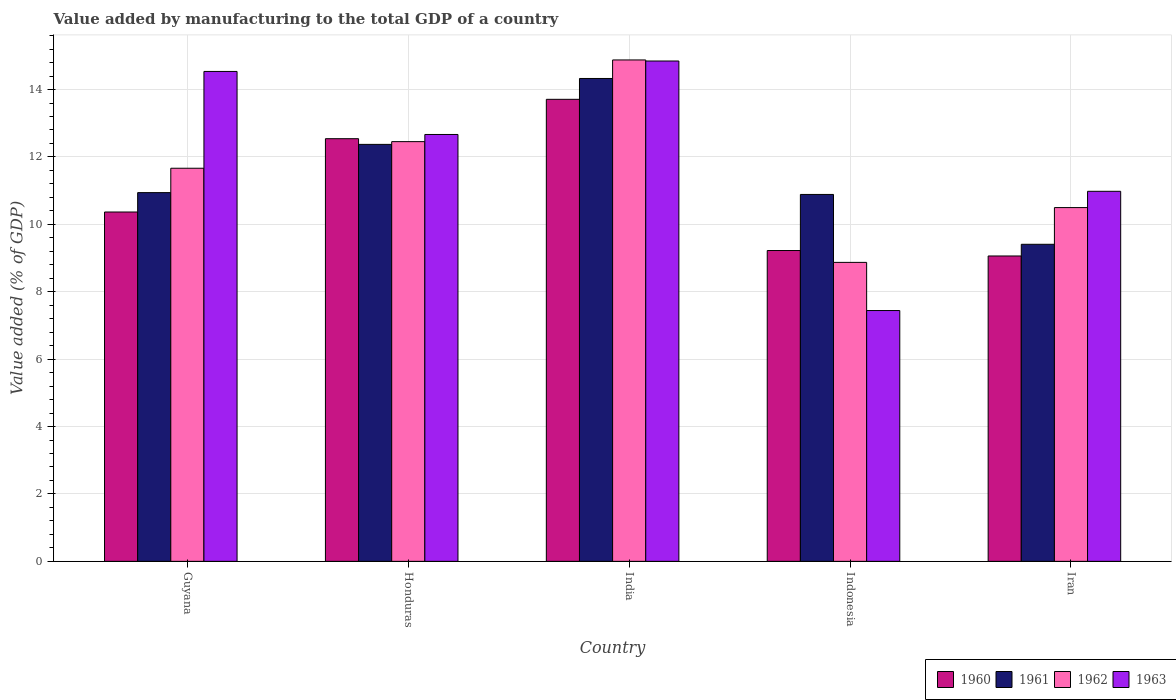How many groups of bars are there?
Give a very brief answer. 5. What is the label of the 1st group of bars from the left?
Ensure brevity in your answer.  Guyana. In how many cases, is the number of bars for a given country not equal to the number of legend labels?
Your answer should be compact. 0. What is the value added by manufacturing to the total GDP in 1961 in Indonesia?
Give a very brief answer. 10.89. Across all countries, what is the maximum value added by manufacturing to the total GDP in 1961?
Make the answer very short. 14.33. Across all countries, what is the minimum value added by manufacturing to the total GDP in 1962?
Give a very brief answer. 8.87. In which country was the value added by manufacturing to the total GDP in 1961 maximum?
Your answer should be compact. India. In which country was the value added by manufacturing to the total GDP in 1963 minimum?
Your answer should be compact. Indonesia. What is the total value added by manufacturing to the total GDP in 1960 in the graph?
Provide a succinct answer. 54.9. What is the difference between the value added by manufacturing to the total GDP in 1963 in Guyana and that in Indonesia?
Your answer should be compact. 7.09. What is the difference between the value added by manufacturing to the total GDP in 1960 in Guyana and the value added by manufacturing to the total GDP in 1962 in Iran?
Offer a terse response. -0.13. What is the average value added by manufacturing to the total GDP in 1960 per country?
Give a very brief answer. 10.98. What is the difference between the value added by manufacturing to the total GDP of/in 1960 and value added by manufacturing to the total GDP of/in 1963 in Iran?
Your answer should be compact. -1.92. What is the ratio of the value added by manufacturing to the total GDP in 1960 in Honduras to that in Indonesia?
Your response must be concise. 1.36. Is the value added by manufacturing to the total GDP in 1963 in Indonesia less than that in Iran?
Your answer should be very brief. Yes. What is the difference between the highest and the second highest value added by manufacturing to the total GDP in 1961?
Offer a very short reply. -1.43. What is the difference between the highest and the lowest value added by manufacturing to the total GDP in 1962?
Give a very brief answer. 6.01. Is the sum of the value added by manufacturing to the total GDP in 1961 in Honduras and Indonesia greater than the maximum value added by manufacturing to the total GDP in 1962 across all countries?
Your answer should be compact. Yes. What does the 4th bar from the left in Honduras represents?
Keep it short and to the point. 1963. How many bars are there?
Give a very brief answer. 20. Are the values on the major ticks of Y-axis written in scientific E-notation?
Your answer should be very brief. No. Where does the legend appear in the graph?
Give a very brief answer. Bottom right. What is the title of the graph?
Ensure brevity in your answer.  Value added by manufacturing to the total GDP of a country. What is the label or title of the Y-axis?
Your answer should be very brief. Value added (% of GDP). What is the Value added (% of GDP) of 1960 in Guyana?
Make the answer very short. 10.37. What is the Value added (% of GDP) in 1961 in Guyana?
Ensure brevity in your answer.  10.94. What is the Value added (% of GDP) of 1962 in Guyana?
Provide a succinct answer. 11.66. What is the Value added (% of GDP) of 1963 in Guyana?
Ensure brevity in your answer.  14.54. What is the Value added (% of GDP) in 1960 in Honduras?
Give a very brief answer. 12.54. What is the Value added (% of GDP) of 1961 in Honduras?
Offer a terse response. 12.37. What is the Value added (% of GDP) in 1962 in Honduras?
Provide a short and direct response. 12.45. What is the Value added (% of GDP) of 1963 in Honduras?
Offer a very short reply. 12.67. What is the Value added (% of GDP) of 1960 in India?
Ensure brevity in your answer.  13.71. What is the Value added (% of GDP) of 1961 in India?
Offer a terse response. 14.33. What is the Value added (% of GDP) in 1962 in India?
Ensure brevity in your answer.  14.88. What is the Value added (% of GDP) in 1963 in India?
Ensure brevity in your answer.  14.85. What is the Value added (% of GDP) in 1960 in Indonesia?
Your answer should be very brief. 9.22. What is the Value added (% of GDP) of 1961 in Indonesia?
Your response must be concise. 10.89. What is the Value added (% of GDP) of 1962 in Indonesia?
Your answer should be very brief. 8.87. What is the Value added (% of GDP) of 1963 in Indonesia?
Provide a short and direct response. 7.44. What is the Value added (% of GDP) in 1960 in Iran?
Offer a terse response. 9.06. What is the Value added (% of GDP) in 1961 in Iran?
Your answer should be very brief. 9.41. What is the Value added (% of GDP) of 1962 in Iran?
Provide a succinct answer. 10.5. What is the Value added (% of GDP) in 1963 in Iran?
Keep it short and to the point. 10.98. Across all countries, what is the maximum Value added (% of GDP) of 1960?
Your answer should be compact. 13.71. Across all countries, what is the maximum Value added (% of GDP) in 1961?
Provide a short and direct response. 14.33. Across all countries, what is the maximum Value added (% of GDP) of 1962?
Your answer should be compact. 14.88. Across all countries, what is the maximum Value added (% of GDP) of 1963?
Offer a very short reply. 14.85. Across all countries, what is the minimum Value added (% of GDP) in 1960?
Offer a terse response. 9.06. Across all countries, what is the minimum Value added (% of GDP) in 1961?
Your answer should be very brief. 9.41. Across all countries, what is the minimum Value added (% of GDP) in 1962?
Offer a very short reply. 8.87. Across all countries, what is the minimum Value added (% of GDP) of 1963?
Give a very brief answer. 7.44. What is the total Value added (% of GDP) in 1960 in the graph?
Provide a succinct answer. 54.9. What is the total Value added (% of GDP) in 1961 in the graph?
Ensure brevity in your answer.  57.94. What is the total Value added (% of GDP) in 1962 in the graph?
Keep it short and to the point. 58.37. What is the total Value added (% of GDP) in 1963 in the graph?
Make the answer very short. 60.47. What is the difference between the Value added (% of GDP) of 1960 in Guyana and that in Honduras?
Provide a succinct answer. -2.18. What is the difference between the Value added (% of GDP) of 1961 in Guyana and that in Honduras?
Your answer should be compact. -1.43. What is the difference between the Value added (% of GDP) of 1962 in Guyana and that in Honduras?
Offer a very short reply. -0.79. What is the difference between the Value added (% of GDP) in 1963 in Guyana and that in Honduras?
Offer a very short reply. 1.87. What is the difference between the Value added (% of GDP) in 1960 in Guyana and that in India?
Offer a very short reply. -3.34. What is the difference between the Value added (% of GDP) of 1961 in Guyana and that in India?
Provide a short and direct response. -3.39. What is the difference between the Value added (% of GDP) in 1962 in Guyana and that in India?
Make the answer very short. -3.21. What is the difference between the Value added (% of GDP) of 1963 in Guyana and that in India?
Ensure brevity in your answer.  -0.31. What is the difference between the Value added (% of GDP) of 1960 in Guyana and that in Indonesia?
Ensure brevity in your answer.  1.14. What is the difference between the Value added (% of GDP) of 1961 in Guyana and that in Indonesia?
Provide a succinct answer. 0.05. What is the difference between the Value added (% of GDP) of 1962 in Guyana and that in Indonesia?
Give a very brief answer. 2.79. What is the difference between the Value added (% of GDP) of 1963 in Guyana and that in Indonesia?
Your response must be concise. 7.09. What is the difference between the Value added (% of GDP) of 1960 in Guyana and that in Iran?
Provide a succinct answer. 1.3. What is the difference between the Value added (% of GDP) of 1961 in Guyana and that in Iran?
Provide a short and direct response. 1.53. What is the difference between the Value added (% of GDP) in 1962 in Guyana and that in Iran?
Give a very brief answer. 1.17. What is the difference between the Value added (% of GDP) of 1963 in Guyana and that in Iran?
Your answer should be very brief. 3.56. What is the difference between the Value added (% of GDP) of 1960 in Honduras and that in India?
Keep it short and to the point. -1.17. What is the difference between the Value added (% of GDP) of 1961 in Honduras and that in India?
Your answer should be very brief. -1.96. What is the difference between the Value added (% of GDP) in 1962 in Honduras and that in India?
Offer a terse response. -2.42. What is the difference between the Value added (% of GDP) of 1963 in Honduras and that in India?
Ensure brevity in your answer.  -2.18. What is the difference between the Value added (% of GDP) in 1960 in Honduras and that in Indonesia?
Your answer should be compact. 3.32. What is the difference between the Value added (% of GDP) in 1961 in Honduras and that in Indonesia?
Offer a very short reply. 1.49. What is the difference between the Value added (% of GDP) in 1962 in Honduras and that in Indonesia?
Keep it short and to the point. 3.58. What is the difference between the Value added (% of GDP) of 1963 in Honduras and that in Indonesia?
Your answer should be very brief. 5.22. What is the difference between the Value added (% of GDP) in 1960 in Honduras and that in Iran?
Your answer should be very brief. 3.48. What is the difference between the Value added (% of GDP) of 1961 in Honduras and that in Iran?
Give a very brief answer. 2.96. What is the difference between the Value added (% of GDP) of 1962 in Honduras and that in Iran?
Provide a short and direct response. 1.96. What is the difference between the Value added (% of GDP) of 1963 in Honduras and that in Iran?
Keep it short and to the point. 1.69. What is the difference between the Value added (% of GDP) in 1960 in India and that in Indonesia?
Provide a short and direct response. 4.49. What is the difference between the Value added (% of GDP) of 1961 in India and that in Indonesia?
Give a very brief answer. 3.44. What is the difference between the Value added (% of GDP) of 1962 in India and that in Indonesia?
Make the answer very short. 6.01. What is the difference between the Value added (% of GDP) in 1963 in India and that in Indonesia?
Ensure brevity in your answer.  7.4. What is the difference between the Value added (% of GDP) of 1960 in India and that in Iran?
Offer a very short reply. 4.65. What is the difference between the Value added (% of GDP) of 1961 in India and that in Iran?
Your response must be concise. 4.92. What is the difference between the Value added (% of GDP) in 1962 in India and that in Iran?
Ensure brevity in your answer.  4.38. What is the difference between the Value added (% of GDP) in 1963 in India and that in Iran?
Provide a succinct answer. 3.87. What is the difference between the Value added (% of GDP) in 1960 in Indonesia and that in Iran?
Ensure brevity in your answer.  0.16. What is the difference between the Value added (% of GDP) in 1961 in Indonesia and that in Iran?
Provide a short and direct response. 1.48. What is the difference between the Value added (% of GDP) in 1962 in Indonesia and that in Iran?
Provide a short and direct response. -1.63. What is the difference between the Value added (% of GDP) of 1963 in Indonesia and that in Iran?
Give a very brief answer. -3.54. What is the difference between the Value added (% of GDP) in 1960 in Guyana and the Value added (% of GDP) in 1961 in Honduras?
Your answer should be compact. -2.01. What is the difference between the Value added (% of GDP) in 1960 in Guyana and the Value added (% of GDP) in 1962 in Honduras?
Provide a short and direct response. -2.09. What is the difference between the Value added (% of GDP) of 1960 in Guyana and the Value added (% of GDP) of 1963 in Honduras?
Ensure brevity in your answer.  -2.3. What is the difference between the Value added (% of GDP) of 1961 in Guyana and the Value added (% of GDP) of 1962 in Honduras?
Ensure brevity in your answer.  -1.51. What is the difference between the Value added (% of GDP) of 1961 in Guyana and the Value added (% of GDP) of 1963 in Honduras?
Your answer should be compact. -1.73. What is the difference between the Value added (% of GDP) in 1962 in Guyana and the Value added (% of GDP) in 1963 in Honduras?
Your answer should be compact. -1. What is the difference between the Value added (% of GDP) of 1960 in Guyana and the Value added (% of GDP) of 1961 in India?
Your answer should be very brief. -3.96. What is the difference between the Value added (% of GDP) in 1960 in Guyana and the Value added (% of GDP) in 1962 in India?
Provide a short and direct response. -4.51. What is the difference between the Value added (% of GDP) of 1960 in Guyana and the Value added (% of GDP) of 1963 in India?
Ensure brevity in your answer.  -4.48. What is the difference between the Value added (% of GDP) of 1961 in Guyana and the Value added (% of GDP) of 1962 in India?
Your answer should be compact. -3.94. What is the difference between the Value added (% of GDP) in 1961 in Guyana and the Value added (% of GDP) in 1963 in India?
Keep it short and to the point. -3.91. What is the difference between the Value added (% of GDP) in 1962 in Guyana and the Value added (% of GDP) in 1963 in India?
Give a very brief answer. -3.18. What is the difference between the Value added (% of GDP) in 1960 in Guyana and the Value added (% of GDP) in 1961 in Indonesia?
Keep it short and to the point. -0.52. What is the difference between the Value added (% of GDP) in 1960 in Guyana and the Value added (% of GDP) in 1962 in Indonesia?
Your answer should be very brief. 1.49. What is the difference between the Value added (% of GDP) of 1960 in Guyana and the Value added (% of GDP) of 1963 in Indonesia?
Ensure brevity in your answer.  2.92. What is the difference between the Value added (% of GDP) in 1961 in Guyana and the Value added (% of GDP) in 1962 in Indonesia?
Your response must be concise. 2.07. What is the difference between the Value added (% of GDP) of 1961 in Guyana and the Value added (% of GDP) of 1963 in Indonesia?
Your answer should be compact. 3.5. What is the difference between the Value added (% of GDP) in 1962 in Guyana and the Value added (% of GDP) in 1963 in Indonesia?
Give a very brief answer. 4.22. What is the difference between the Value added (% of GDP) of 1960 in Guyana and the Value added (% of GDP) of 1961 in Iran?
Give a very brief answer. 0.96. What is the difference between the Value added (% of GDP) in 1960 in Guyana and the Value added (% of GDP) in 1962 in Iran?
Make the answer very short. -0.13. What is the difference between the Value added (% of GDP) in 1960 in Guyana and the Value added (% of GDP) in 1963 in Iran?
Your response must be concise. -0.61. What is the difference between the Value added (% of GDP) in 1961 in Guyana and the Value added (% of GDP) in 1962 in Iran?
Offer a terse response. 0.44. What is the difference between the Value added (% of GDP) of 1961 in Guyana and the Value added (% of GDP) of 1963 in Iran?
Ensure brevity in your answer.  -0.04. What is the difference between the Value added (% of GDP) in 1962 in Guyana and the Value added (% of GDP) in 1963 in Iran?
Keep it short and to the point. 0.68. What is the difference between the Value added (% of GDP) of 1960 in Honduras and the Value added (% of GDP) of 1961 in India?
Your response must be concise. -1.79. What is the difference between the Value added (% of GDP) in 1960 in Honduras and the Value added (% of GDP) in 1962 in India?
Your answer should be very brief. -2.34. What is the difference between the Value added (% of GDP) of 1960 in Honduras and the Value added (% of GDP) of 1963 in India?
Keep it short and to the point. -2.31. What is the difference between the Value added (% of GDP) of 1961 in Honduras and the Value added (% of GDP) of 1962 in India?
Make the answer very short. -2.51. What is the difference between the Value added (% of GDP) in 1961 in Honduras and the Value added (% of GDP) in 1963 in India?
Your answer should be compact. -2.47. What is the difference between the Value added (% of GDP) of 1962 in Honduras and the Value added (% of GDP) of 1963 in India?
Make the answer very short. -2.39. What is the difference between the Value added (% of GDP) of 1960 in Honduras and the Value added (% of GDP) of 1961 in Indonesia?
Offer a terse response. 1.65. What is the difference between the Value added (% of GDP) in 1960 in Honduras and the Value added (% of GDP) in 1962 in Indonesia?
Keep it short and to the point. 3.67. What is the difference between the Value added (% of GDP) of 1960 in Honduras and the Value added (% of GDP) of 1963 in Indonesia?
Give a very brief answer. 5.1. What is the difference between the Value added (% of GDP) of 1961 in Honduras and the Value added (% of GDP) of 1962 in Indonesia?
Your answer should be compact. 3.5. What is the difference between the Value added (% of GDP) of 1961 in Honduras and the Value added (% of GDP) of 1963 in Indonesia?
Give a very brief answer. 4.93. What is the difference between the Value added (% of GDP) of 1962 in Honduras and the Value added (% of GDP) of 1963 in Indonesia?
Give a very brief answer. 5.01. What is the difference between the Value added (% of GDP) of 1960 in Honduras and the Value added (% of GDP) of 1961 in Iran?
Make the answer very short. 3.13. What is the difference between the Value added (% of GDP) in 1960 in Honduras and the Value added (% of GDP) in 1962 in Iran?
Provide a succinct answer. 2.04. What is the difference between the Value added (% of GDP) of 1960 in Honduras and the Value added (% of GDP) of 1963 in Iran?
Make the answer very short. 1.56. What is the difference between the Value added (% of GDP) in 1961 in Honduras and the Value added (% of GDP) in 1962 in Iran?
Keep it short and to the point. 1.88. What is the difference between the Value added (% of GDP) in 1961 in Honduras and the Value added (% of GDP) in 1963 in Iran?
Offer a terse response. 1.39. What is the difference between the Value added (% of GDP) of 1962 in Honduras and the Value added (% of GDP) of 1963 in Iran?
Make the answer very short. 1.47. What is the difference between the Value added (% of GDP) of 1960 in India and the Value added (% of GDP) of 1961 in Indonesia?
Provide a short and direct response. 2.82. What is the difference between the Value added (% of GDP) of 1960 in India and the Value added (% of GDP) of 1962 in Indonesia?
Keep it short and to the point. 4.84. What is the difference between the Value added (% of GDP) in 1960 in India and the Value added (% of GDP) in 1963 in Indonesia?
Offer a terse response. 6.27. What is the difference between the Value added (% of GDP) of 1961 in India and the Value added (% of GDP) of 1962 in Indonesia?
Offer a terse response. 5.46. What is the difference between the Value added (% of GDP) of 1961 in India and the Value added (% of GDP) of 1963 in Indonesia?
Make the answer very short. 6.89. What is the difference between the Value added (% of GDP) of 1962 in India and the Value added (% of GDP) of 1963 in Indonesia?
Provide a short and direct response. 7.44. What is the difference between the Value added (% of GDP) of 1960 in India and the Value added (% of GDP) of 1961 in Iran?
Offer a very short reply. 4.3. What is the difference between the Value added (% of GDP) of 1960 in India and the Value added (% of GDP) of 1962 in Iran?
Ensure brevity in your answer.  3.21. What is the difference between the Value added (% of GDP) of 1960 in India and the Value added (% of GDP) of 1963 in Iran?
Offer a very short reply. 2.73. What is the difference between the Value added (% of GDP) of 1961 in India and the Value added (% of GDP) of 1962 in Iran?
Your answer should be compact. 3.83. What is the difference between the Value added (% of GDP) in 1961 in India and the Value added (% of GDP) in 1963 in Iran?
Give a very brief answer. 3.35. What is the difference between the Value added (% of GDP) in 1962 in India and the Value added (% of GDP) in 1963 in Iran?
Make the answer very short. 3.9. What is the difference between the Value added (% of GDP) in 1960 in Indonesia and the Value added (% of GDP) in 1961 in Iran?
Ensure brevity in your answer.  -0.18. What is the difference between the Value added (% of GDP) in 1960 in Indonesia and the Value added (% of GDP) in 1962 in Iran?
Your answer should be very brief. -1.27. What is the difference between the Value added (% of GDP) in 1960 in Indonesia and the Value added (% of GDP) in 1963 in Iran?
Your response must be concise. -1.76. What is the difference between the Value added (% of GDP) of 1961 in Indonesia and the Value added (% of GDP) of 1962 in Iran?
Ensure brevity in your answer.  0.39. What is the difference between the Value added (% of GDP) in 1961 in Indonesia and the Value added (% of GDP) in 1963 in Iran?
Your response must be concise. -0.09. What is the difference between the Value added (% of GDP) in 1962 in Indonesia and the Value added (% of GDP) in 1963 in Iran?
Keep it short and to the point. -2.11. What is the average Value added (% of GDP) in 1960 per country?
Your response must be concise. 10.98. What is the average Value added (% of GDP) in 1961 per country?
Give a very brief answer. 11.59. What is the average Value added (% of GDP) in 1962 per country?
Offer a very short reply. 11.67. What is the average Value added (% of GDP) of 1963 per country?
Offer a terse response. 12.09. What is the difference between the Value added (% of GDP) in 1960 and Value added (% of GDP) in 1961 in Guyana?
Make the answer very short. -0.58. What is the difference between the Value added (% of GDP) of 1960 and Value added (% of GDP) of 1962 in Guyana?
Your answer should be compact. -1.3. What is the difference between the Value added (% of GDP) in 1960 and Value added (% of GDP) in 1963 in Guyana?
Your response must be concise. -4.17. What is the difference between the Value added (% of GDP) of 1961 and Value added (% of GDP) of 1962 in Guyana?
Your response must be concise. -0.72. What is the difference between the Value added (% of GDP) of 1961 and Value added (% of GDP) of 1963 in Guyana?
Make the answer very short. -3.6. What is the difference between the Value added (% of GDP) of 1962 and Value added (% of GDP) of 1963 in Guyana?
Provide a succinct answer. -2.87. What is the difference between the Value added (% of GDP) of 1960 and Value added (% of GDP) of 1961 in Honduras?
Your answer should be compact. 0.17. What is the difference between the Value added (% of GDP) in 1960 and Value added (% of GDP) in 1962 in Honduras?
Provide a succinct answer. 0.09. What is the difference between the Value added (% of GDP) of 1960 and Value added (% of GDP) of 1963 in Honduras?
Provide a succinct answer. -0.13. What is the difference between the Value added (% of GDP) of 1961 and Value added (% of GDP) of 1962 in Honduras?
Your answer should be very brief. -0.08. What is the difference between the Value added (% of GDP) in 1961 and Value added (% of GDP) in 1963 in Honduras?
Keep it short and to the point. -0.29. What is the difference between the Value added (% of GDP) in 1962 and Value added (% of GDP) in 1963 in Honduras?
Your answer should be very brief. -0.21. What is the difference between the Value added (% of GDP) in 1960 and Value added (% of GDP) in 1961 in India?
Provide a succinct answer. -0.62. What is the difference between the Value added (% of GDP) in 1960 and Value added (% of GDP) in 1962 in India?
Keep it short and to the point. -1.17. What is the difference between the Value added (% of GDP) in 1960 and Value added (% of GDP) in 1963 in India?
Give a very brief answer. -1.14. What is the difference between the Value added (% of GDP) in 1961 and Value added (% of GDP) in 1962 in India?
Keep it short and to the point. -0.55. What is the difference between the Value added (% of GDP) in 1961 and Value added (% of GDP) in 1963 in India?
Your response must be concise. -0.52. What is the difference between the Value added (% of GDP) of 1962 and Value added (% of GDP) of 1963 in India?
Your answer should be compact. 0.03. What is the difference between the Value added (% of GDP) in 1960 and Value added (% of GDP) in 1961 in Indonesia?
Your answer should be very brief. -1.66. What is the difference between the Value added (% of GDP) of 1960 and Value added (% of GDP) of 1962 in Indonesia?
Provide a succinct answer. 0.35. What is the difference between the Value added (% of GDP) of 1960 and Value added (% of GDP) of 1963 in Indonesia?
Ensure brevity in your answer.  1.78. What is the difference between the Value added (% of GDP) in 1961 and Value added (% of GDP) in 1962 in Indonesia?
Your response must be concise. 2.02. What is the difference between the Value added (% of GDP) in 1961 and Value added (% of GDP) in 1963 in Indonesia?
Your answer should be compact. 3.44. What is the difference between the Value added (% of GDP) in 1962 and Value added (% of GDP) in 1963 in Indonesia?
Your answer should be compact. 1.43. What is the difference between the Value added (% of GDP) in 1960 and Value added (% of GDP) in 1961 in Iran?
Make the answer very short. -0.35. What is the difference between the Value added (% of GDP) in 1960 and Value added (% of GDP) in 1962 in Iran?
Give a very brief answer. -1.44. What is the difference between the Value added (% of GDP) of 1960 and Value added (% of GDP) of 1963 in Iran?
Make the answer very short. -1.92. What is the difference between the Value added (% of GDP) of 1961 and Value added (% of GDP) of 1962 in Iran?
Keep it short and to the point. -1.09. What is the difference between the Value added (% of GDP) in 1961 and Value added (% of GDP) in 1963 in Iran?
Give a very brief answer. -1.57. What is the difference between the Value added (% of GDP) in 1962 and Value added (% of GDP) in 1963 in Iran?
Give a very brief answer. -0.48. What is the ratio of the Value added (% of GDP) of 1960 in Guyana to that in Honduras?
Your response must be concise. 0.83. What is the ratio of the Value added (% of GDP) in 1961 in Guyana to that in Honduras?
Keep it short and to the point. 0.88. What is the ratio of the Value added (% of GDP) in 1962 in Guyana to that in Honduras?
Offer a very short reply. 0.94. What is the ratio of the Value added (% of GDP) in 1963 in Guyana to that in Honduras?
Keep it short and to the point. 1.15. What is the ratio of the Value added (% of GDP) of 1960 in Guyana to that in India?
Provide a short and direct response. 0.76. What is the ratio of the Value added (% of GDP) in 1961 in Guyana to that in India?
Provide a succinct answer. 0.76. What is the ratio of the Value added (% of GDP) in 1962 in Guyana to that in India?
Make the answer very short. 0.78. What is the ratio of the Value added (% of GDP) in 1963 in Guyana to that in India?
Your answer should be very brief. 0.98. What is the ratio of the Value added (% of GDP) in 1960 in Guyana to that in Indonesia?
Make the answer very short. 1.12. What is the ratio of the Value added (% of GDP) in 1962 in Guyana to that in Indonesia?
Your answer should be compact. 1.31. What is the ratio of the Value added (% of GDP) in 1963 in Guyana to that in Indonesia?
Your answer should be compact. 1.95. What is the ratio of the Value added (% of GDP) in 1960 in Guyana to that in Iran?
Keep it short and to the point. 1.14. What is the ratio of the Value added (% of GDP) of 1961 in Guyana to that in Iran?
Offer a terse response. 1.16. What is the ratio of the Value added (% of GDP) of 1962 in Guyana to that in Iran?
Provide a short and direct response. 1.11. What is the ratio of the Value added (% of GDP) of 1963 in Guyana to that in Iran?
Ensure brevity in your answer.  1.32. What is the ratio of the Value added (% of GDP) in 1960 in Honduras to that in India?
Ensure brevity in your answer.  0.91. What is the ratio of the Value added (% of GDP) of 1961 in Honduras to that in India?
Your response must be concise. 0.86. What is the ratio of the Value added (% of GDP) in 1962 in Honduras to that in India?
Your answer should be compact. 0.84. What is the ratio of the Value added (% of GDP) of 1963 in Honduras to that in India?
Provide a succinct answer. 0.85. What is the ratio of the Value added (% of GDP) in 1960 in Honduras to that in Indonesia?
Ensure brevity in your answer.  1.36. What is the ratio of the Value added (% of GDP) of 1961 in Honduras to that in Indonesia?
Offer a very short reply. 1.14. What is the ratio of the Value added (% of GDP) of 1962 in Honduras to that in Indonesia?
Your response must be concise. 1.4. What is the ratio of the Value added (% of GDP) in 1963 in Honduras to that in Indonesia?
Offer a very short reply. 1.7. What is the ratio of the Value added (% of GDP) in 1960 in Honduras to that in Iran?
Keep it short and to the point. 1.38. What is the ratio of the Value added (% of GDP) in 1961 in Honduras to that in Iran?
Your answer should be very brief. 1.32. What is the ratio of the Value added (% of GDP) of 1962 in Honduras to that in Iran?
Keep it short and to the point. 1.19. What is the ratio of the Value added (% of GDP) of 1963 in Honduras to that in Iran?
Offer a very short reply. 1.15. What is the ratio of the Value added (% of GDP) of 1960 in India to that in Indonesia?
Provide a short and direct response. 1.49. What is the ratio of the Value added (% of GDP) of 1961 in India to that in Indonesia?
Your response must be concise. 1.32. What is the ratio of the Value added (% of GDP) in 1962 in India to that in Indonesia?
Your response must be concise. 1.68. What is the ratio of the Value added (% of GDP) in 1963 in India to that in Indonesia?
Provide a short and direct response. 1.99. What is the ratio of the Value added (% of GDP) of 1960 in India to that in Iran?
Make the answer very short. 1.51. What is the ratio of the Value added (% of GDP) of 1961 in India to that in Iran?
Keep it short and to the point. 1.52. What is the ratio of the Value added (% of GDP) of 1962 in India to that in Iran?
Keep it short and to the point. 1.42. What is the ratio of the Value added (% of GDP) in 1963 in India to that in Iran?
Offer a terse response. 1.35. What is the ratio of the Value added (% of GDP) of 1960 in Indonesia to that in Iran?
Provide a short and direct response. 1.02. What is the ratio of the Value added (% of GDP) of 1961 in Indonesia to that in Iran?
Offer a very short reply. 1.16. What is the ratio of the Value added (% of GDP) of 1962 in Indonesia to that in Iran?
Your answer should be compact. 0.85. What is the ratio of the Value added (% of GDP) in 1963 in Indonesia to that in Iran?
Keep it short and to the point. 0.68. What is the difference between the highest and the second highest Value added (% of GDP) of 1960?
Make the answer very short. 1.17. What is the difference between the highest and the second highest Value added (% of GDP) of 1961?
Your answer should be compact. 1.96. What is the difference between the highest and the second highest Value added (% of GDP) in 1962?
Keep it short and to the point. 2.42. What is the difference between the highest and the second highest Value added (% of GDP) of 1963?
Your response must be concise. 0.31. What is the difference between the highest and the lowest Value added (% of GDP) of 1960?
Your answer should be very brief. 4.65. What is the difference between the highest and the lowest Value added (% of GDP) of 1961?
Offer a terse response. 4.92. What is the difference between the highest and the lowest Value added (% of GDP) in 1962?
Offer a very short reply. 6.01. What is the difference between the highest and the lowest Value added (% of GDP) in 1963?
Provide a succinct answer. 7.4. 